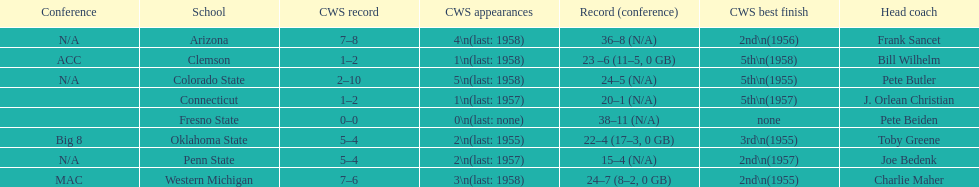How many teams had their cws best finish in 1955? 3. 